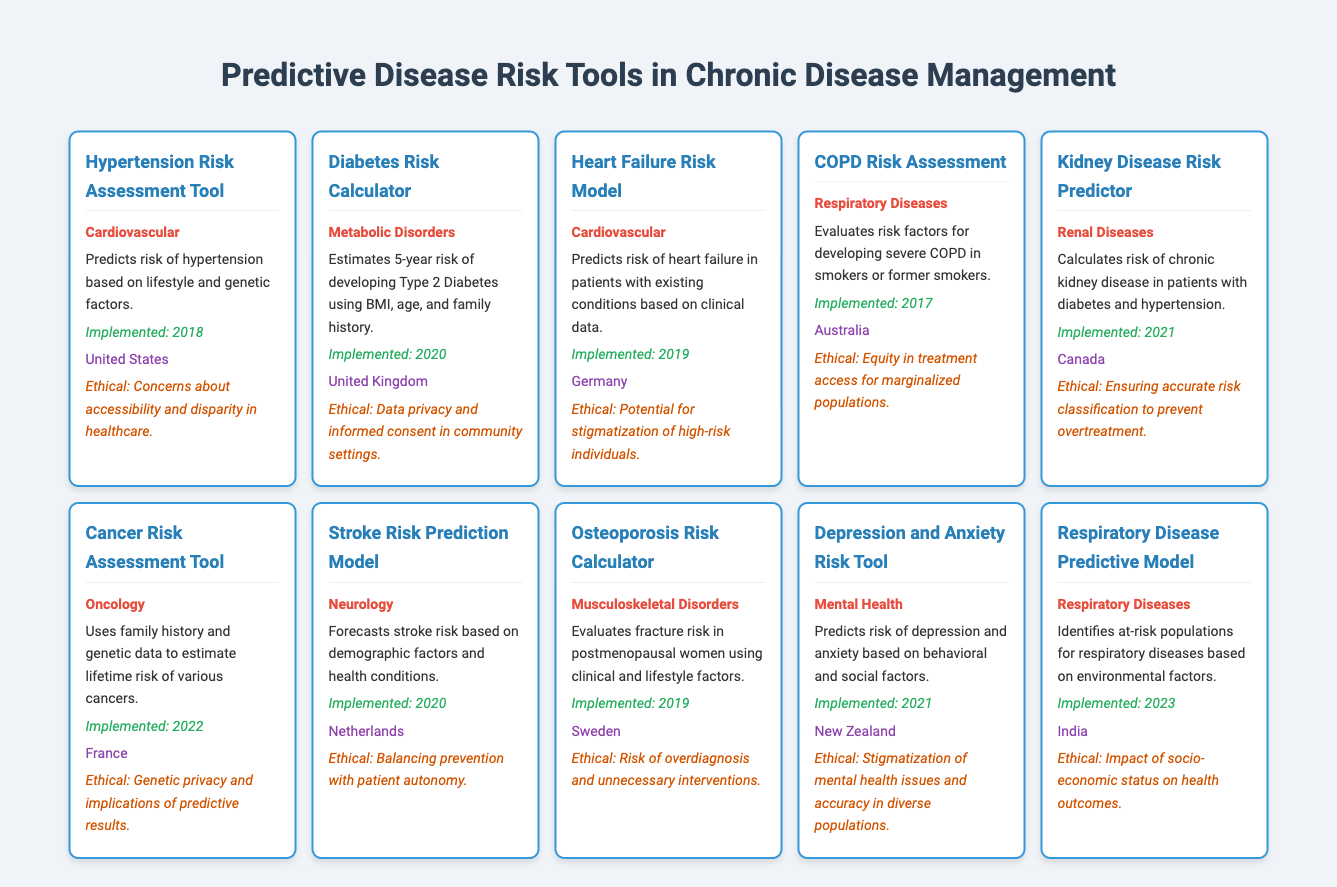What is the usage of the Cancer Risk Assessment Tool? The table states that the Cancer Risk Assessment Tool "uses family history and genetic data to estimate lifetime risk of various cancers."
Answer: uses family history and genetic data to estimate lifetime risk of various cancers Which disease risk tool was implemented in Germany? According to the table, the Heart Failure Risk Model was implemented in Germany in 2019.
Answer: Heart Failure Risk Model What are the ethical considerations related to the Diabetes Risk Calculator? The table notes that the ethical considerations for the Diabetes Risk Calculator involve "data privacy and informed consent in community settings."
Answer: Data privacy and informed consent in community settings How many tools were implemented in 2021? Referring to the table, I can see two tools were implemented in 2021: the Kidney Disease Risk Predictor and the Depression and Anxiety Risk Tool. Thus, the total is 2.
Answer: 2 Is there a risk assessment tool for Cancer in this table? Yes, the table lists a Cancer Risk Assessment Tool, confirming that a tool specifically for cancer exists.
Answer: Yes List the years in which cardiovascular disease tools were implemented. From the table, the tools related to cardiovascular diseases are the Hypertension Risk Assessment Tool (2018), the Heart Failure Risk Model (2019), and the Stroke Risk Prediction Model (2020). Therefore, the years are 2018, 2019, and 2020.
Answer: 2018, 2019, 2020 Which tool has the ethical consideration concerning stigmatization? The Heart Failure Risk Model is associated with the ethical consideration of "potential for stigmatization of high-risk individuals," as stated in the table.
Answer: Heart Failure Risk Model What is the common theme in the ethical considerations for tools related to Respiratory Diseases? The ethical considerations for both the COPD Risk Assessment and the Respiratory Disease Predictive Model highlight issues like equity in treatment access and socio-economic status impacts on health outcomes, suggesting a concern for fairness and access in these populations.
Answer: Equity in treatment access and socio-economic status impacts What is the overall trend in the implementation years of predictive tools listed? Analyzing the years, there is an increase in implementation from 2017 to 2023, indicating a growing trend in developing and utilizing these predictive tools over time.
Answer: Increasing trend from 2017 to 2023 